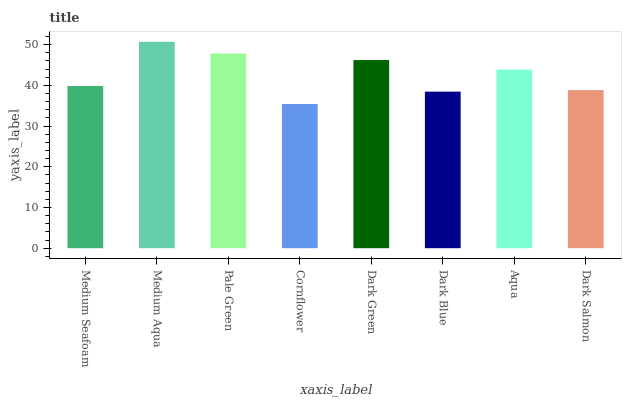Is Cornflower the minimum?
Answer yes or no. Yes. Is Medium Aqua the maximum?
Answer yes or no. Yes. Is Pale Green the minimum?
Answer yes or no. No. Is Pale Green the maximum?
Answer yes or no. No. Is Medium Aqua greater than Pale Green?
Answer yes or no. Yes. Is Pale Green less than Medium Aqua?
Answer yes or no. Yes. Is Pale Green greater than Medium Aqua?
Answer yes or no. No. Is Medium Aqua less than Pale Green?
Answer yes or no. No. Is Aqua the high median?
Answer yes or no. Yes. Is Medium Seafoam the low median?
Answer yes or no. Yes. Is Medium Seafoam the high median?
Answer yes or no. No. Is Dark Blue the low median?
Answer yes or no. No. 